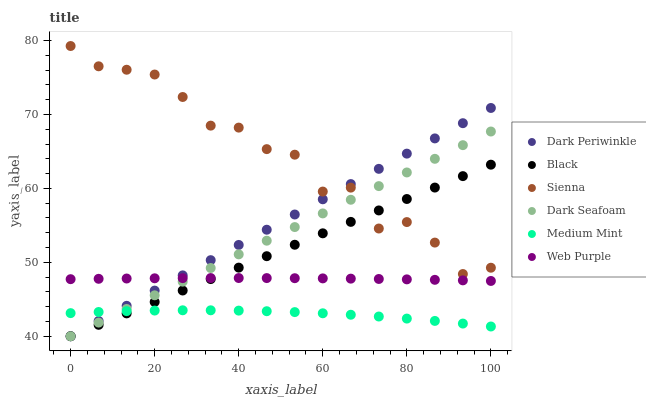Does Medium Mint have the minimum area under the curve?
Answer yes or no. Yes. Does Sienna have the maximum area under the curve?
Answer yes or no. Yes. Does Web Purple have the minimum area under the curve?
Answer yes or no. No. Does Web Purple have the maximum area under the curve?
Answer yes or no. No. Is Dark Seafoam the smoothest?
Answer yes or no. Yes. Is Sienna the roughest?
Answer yes or no. Yes. Is Web Purple the smoothest?
Answer yes or no. No. Is Web Purple the roughest?
Answer yes or no. No. Does Dark Seafoam have the lowest value?
Answer yes or no. Yes. Does Web Purple have the lowest value?
Answer yes or no. No. Does Sienna have the highest value?
Answer yes or no. Yes. Does Web Purple have the highest value?
Answer yes or no. No. Is Medium Mint less than Sienna?
Answer yes or no. Yes. Is Sienna greater than Medium Mint?
Answer yes or no. Yes. Does Sienna intersect Dark Periwinkle?
Answer yes or no. Yes. Is Sienna less than Dark Periwinkle?
Answer yes or no. No. Is Sienna greater than Dark Periwinkle?
Answer yes or no. No. Does Medium Mint intersect Sienna?
Answer yes or no. No. 